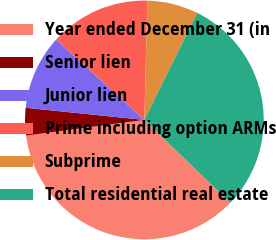<chart> <loc_0><loc_0><loc_500><loc_500><pie_chart><fcel>Year ended December 31 (in<fcel>Senior lien<fcel>Junior lien<fcel>Prime including option ARMs<fcel>Subprime<fcel>Total residential real estate<nl><fcel>35.69%<fcel>3.72%<fcel>10.12%<fcel>13.65%<fcel>6.92%<fcel>29.91%<nl></chart> 